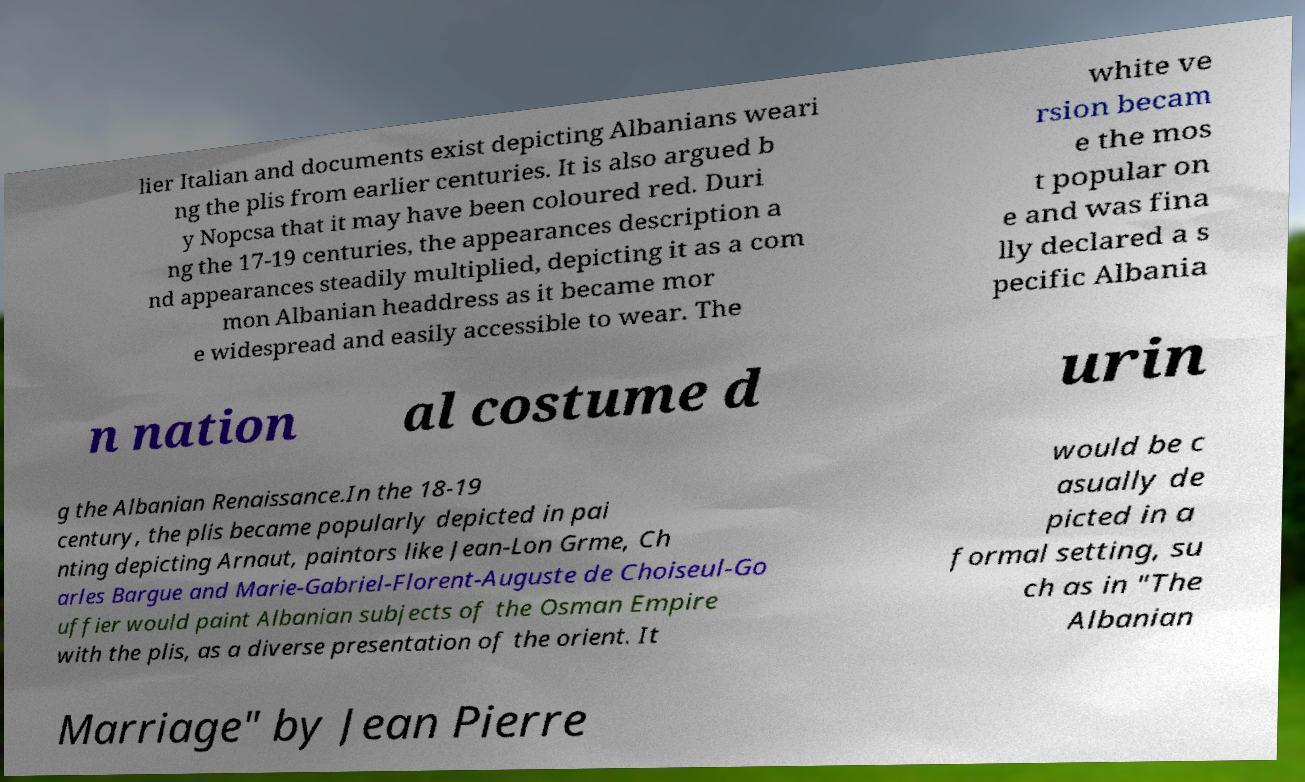I need the written content from this picture converted into text. Can you do that? lier Italian and documents exist depicting Albanians weari ng the plis from earlier centuries. It is also argued b y Nopcsa that it may have been coloured red. Duri ng the 17-19 centuries, the appearances description a nd appearances steadily multiplied, depicting it as a com mon Albanian headdress as it became mor e widespread and easily accessible to wear. The white ve rsion becam e the mos t popular on e and was fina lly declared a s pecific Albania n nation al costume d urin g the Albanian Renaissance.In the 18-19 century, the plis became popularly depicted in pai nting depicting Arnaut, paintors like Jean-Lon Grme, Ch arles Bargue and Marie-Gabriel-Florent-Auguste de Choiseul-Go uffier would paint Albanian subjects of the Osman Empire with the plis, as a diverse presentation of the orient. It would be c asually de picted in a formal setting, su ch as in "The Albanian Marriage" by Jean Pierre 